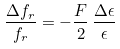<formula> <loc_0><loc_0><loc_500><loc_500>\frac { \Delta f _ { r } } { f _ { r } } = - \frac { F } { 2 } \, \frac { \Delta \epsilon } { \epsilon }</formula> 